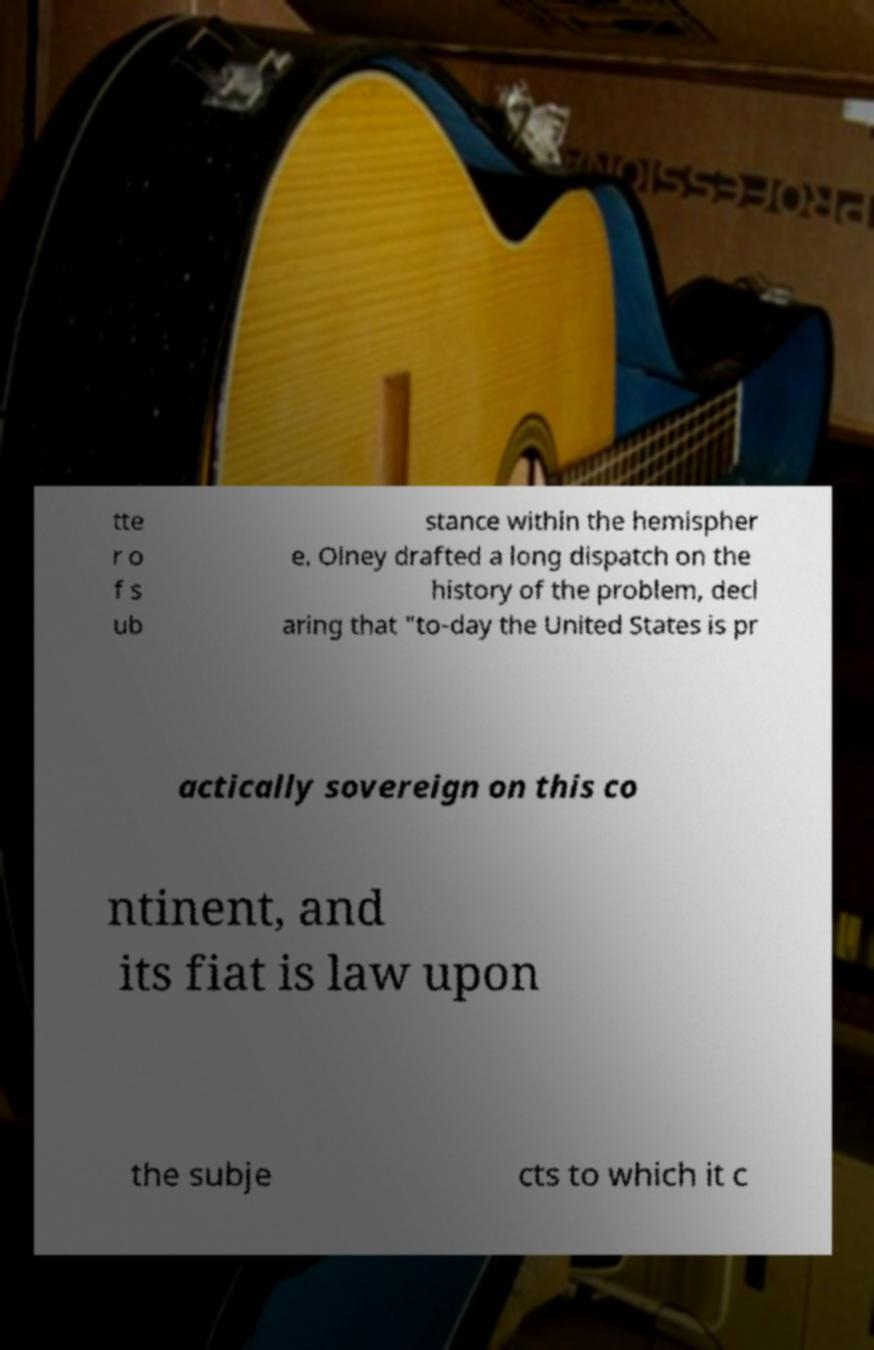I need the written content from this picture converted into text. Can you do that? tte r o f s ub stance within the hemispher e. Olney drafted a long dispatch on the history of the problem, decl aring that "to-day the United States is pr actically sovereign on this co ntinent, and its fiat is law upon the subje cts to which it c 